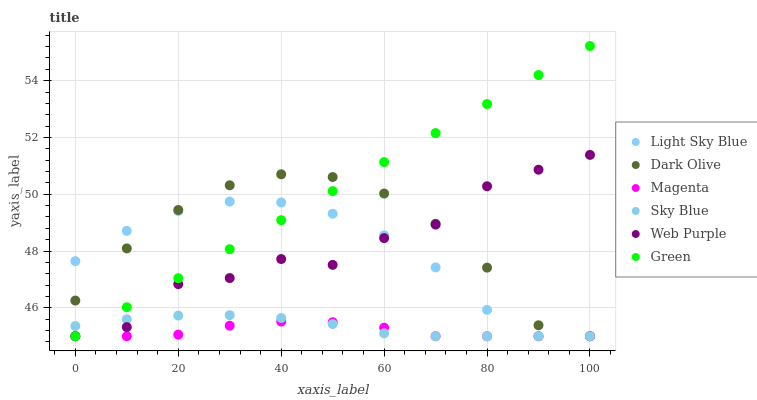Does Magenta have the minimum area under the curve?
Answer yes or no. Yes. Does Green have the maximum area under the curve?
Answer yes or no. Yes. Does Web Purple have the minimum area under the curve?
Answer yes or no. No. Does Web Purple have the maximum area under the curve?
Answer yes or no. No. Is Green the smoothest?
Answer yes or no. Yes. Is Web Purple the roughest?
Answer yes or no. Yes. Is Light Sky Blue the smoothest?
Answer yes or no. No. Is Light Sky Blue the roughest?
Answer yes or no. No. Does Dark Olive have the lowest value?
Answer yes or no. Yes. Does Green have the highest value?
Answer yes or no. Yes. Does Web Purple have the highest value?
Answer yes or no. No. Does Sky Blue intersect Web Purple?
Answer yes or no. Yes. Is Sky Blue less than Web Purple?
Answer yes or no. No. Is Sky Blue greater than Web Purple?
Answer yes or no. No. 